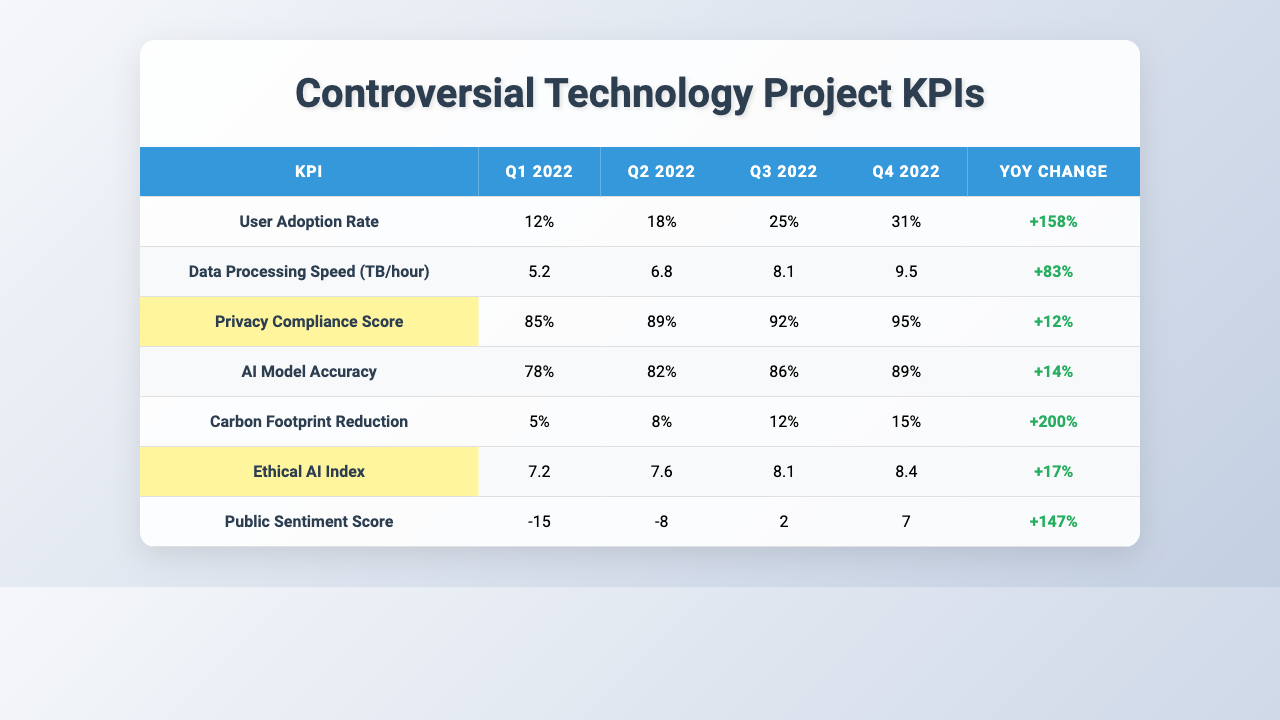What was the User Adoption Rate in Q4 2022? In Q4 2022, the User Adoption Rate is listed directly in the table under the corresponding column, which shows 31%.
Answer: 31% What is the YoY Change for Data Processing Speed? The YoY Change for Data Processing Speed is located in the table, and it states "+83%".
Answer: +83% Was the Privacy Compliance Score above 90% in Q4 2022? Looking at the Q4 2022 row for the Privacy Compliance Score in the table, it reads 95%, which is above 90%.
Answer: Yes Which KPI experienced the highest YoY Change? We need to compare the YoY Change values across all KPIs displayed in the table; the Carbon Footprint Reduction shows the highest increase at +200%.
Answer: Carbon Footprint Reduction What is the average AI Model Accuracy over the four quarters? Adding the AI Model Accuracy values: (78% + 82% + 86% + 89%) = 335%, and then dividing by 4 gives an average of 83.75%.
Answer: 83.75% Is the Public Sentiment Score positive at the end of Q4 2022? Referring to the Q4 2022 row for Public Sentiment Score, it shows 7, which is positive.
Answer: Yes How much did the Carbon Footprint Reduction change from Q1 to Q4 2022? The values for Carbon Footprint Reduction are 5% in Q1 and 15% in Q4, so the change is 15% - 5% = 10%.
Answer: 10% What is the difference between Q2 and Q3 in User Adoption Rate? The User Adoption Rates for Q2 and Q3 are 18% and 25% respectively, so the difference is 25% - 18% = 7%.
Answer: 7% Did the Ethical AI Index improve overall throughout the year? By checking the Ethical AI Index from Q1 (7.2) to Q4 (8.4), we see an increase, indicating improvement.
Answer: Yes What is the trend observed in the Public Sentiment Score over the quarters? Observing the Public Sentiment Score, it changes from -15 to 7, indicating a significant improvement from negative to positive over the year.
Answer: Improvement 